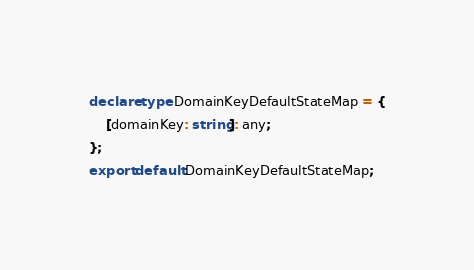Convert code to text. <code><loc_0><loc_0><loc_500><loc_500><_TypeScript_>declare type DomainKeyDefaultStateMap = {
    [domainKey: string]: any;
};
export default DomainKeyDefaultStateMap;
</code> 